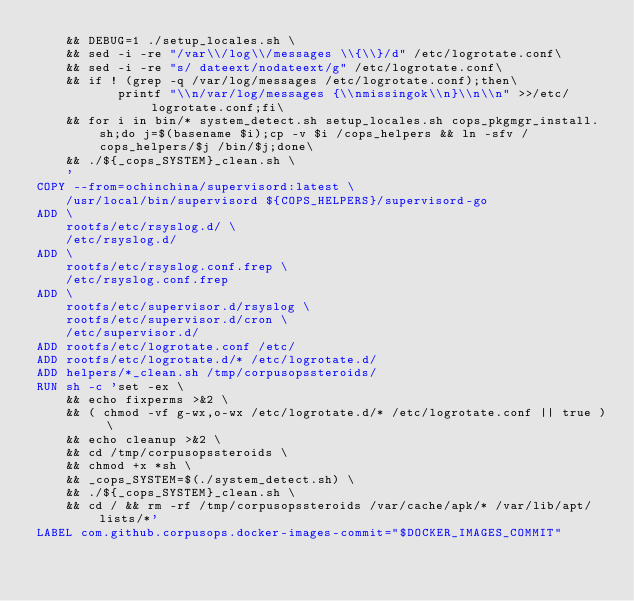Convert code to text. <code><loc_0><loc_0><loc_500><loc_500><_Dockerfile_>    && DEBUG=1 ./setup_locales.sh \
    && sed -i -re "/var\\/log\\/messages \\{\\}/d" /etc/logrotate.conf\
    && sed -i -re "s/ dateext/nodateext/g" /etc/logrotate.conf\
    && if ! (grep -q /var/log/messages /etc/logrotate.conf);then\
           printf "\\n/var/log/messages {\\nmissingok\\n}\\n\\n" >>/etc/logrotate.conf;fi\
    && for i in bin/* system_detect.sh setup_locales.sh cops_pkgmgr_install.sh;do j=$(basename $i);cp -v $i /cops_helpers && ln -sfv /cops_helpers/$j /bin/$j;done\
    && ./${_cops_SYSTEM}_clean.sh \
    '
COPY --from=ochinchina/supervisord:latest \
    /usr/local/bin/supervisord ${COPS_HELPERS}/supervisord-go
ADD \
    rootfs/etc/rsyslog.d/ \
    /etc/rsyslog.d/
ADD \
    rootfs/etc/rsyslog.conf.frep \
    /etc/rsyslog.conf.frep
ADD \
    rootfs/etc/supervisor.d/rsyslog \
    rootfs/etc/supervisor.d/cron \
    /etc/supervisor.d/
ADD rootfs/etc/logrotate.conf /etc/
ADD rootfs/etc/logrotate.d/* /etc/logrotate.d/
ADD helpers/*_clean.sh /tmp/corpusopssteroids/
RUN sh -c 'set -ex \
    && echo fixperms >&2 \
    && ( chmod -vf g-wx,o-wx /etc/logrotate.d/* /etc/logrotate.conf || true ) \
    && echo cleanup >&2 \
    && cd /tmp/corpusopssteroids \
    && chmod +x *sh \
    && _cops_SYSTEM=$(./system_detect.sh) \
    && ./${_cops_SYSTEM}_clean.sh \
    && cd / && rm -rf /tmp/corpusopssteroids /var/cache/apk/* /var/lib/apt/lists/*'
LABEL com.github.corpusops.docker-images-commit="$DOCKER_IMAGES_COMMIT"
</code> 